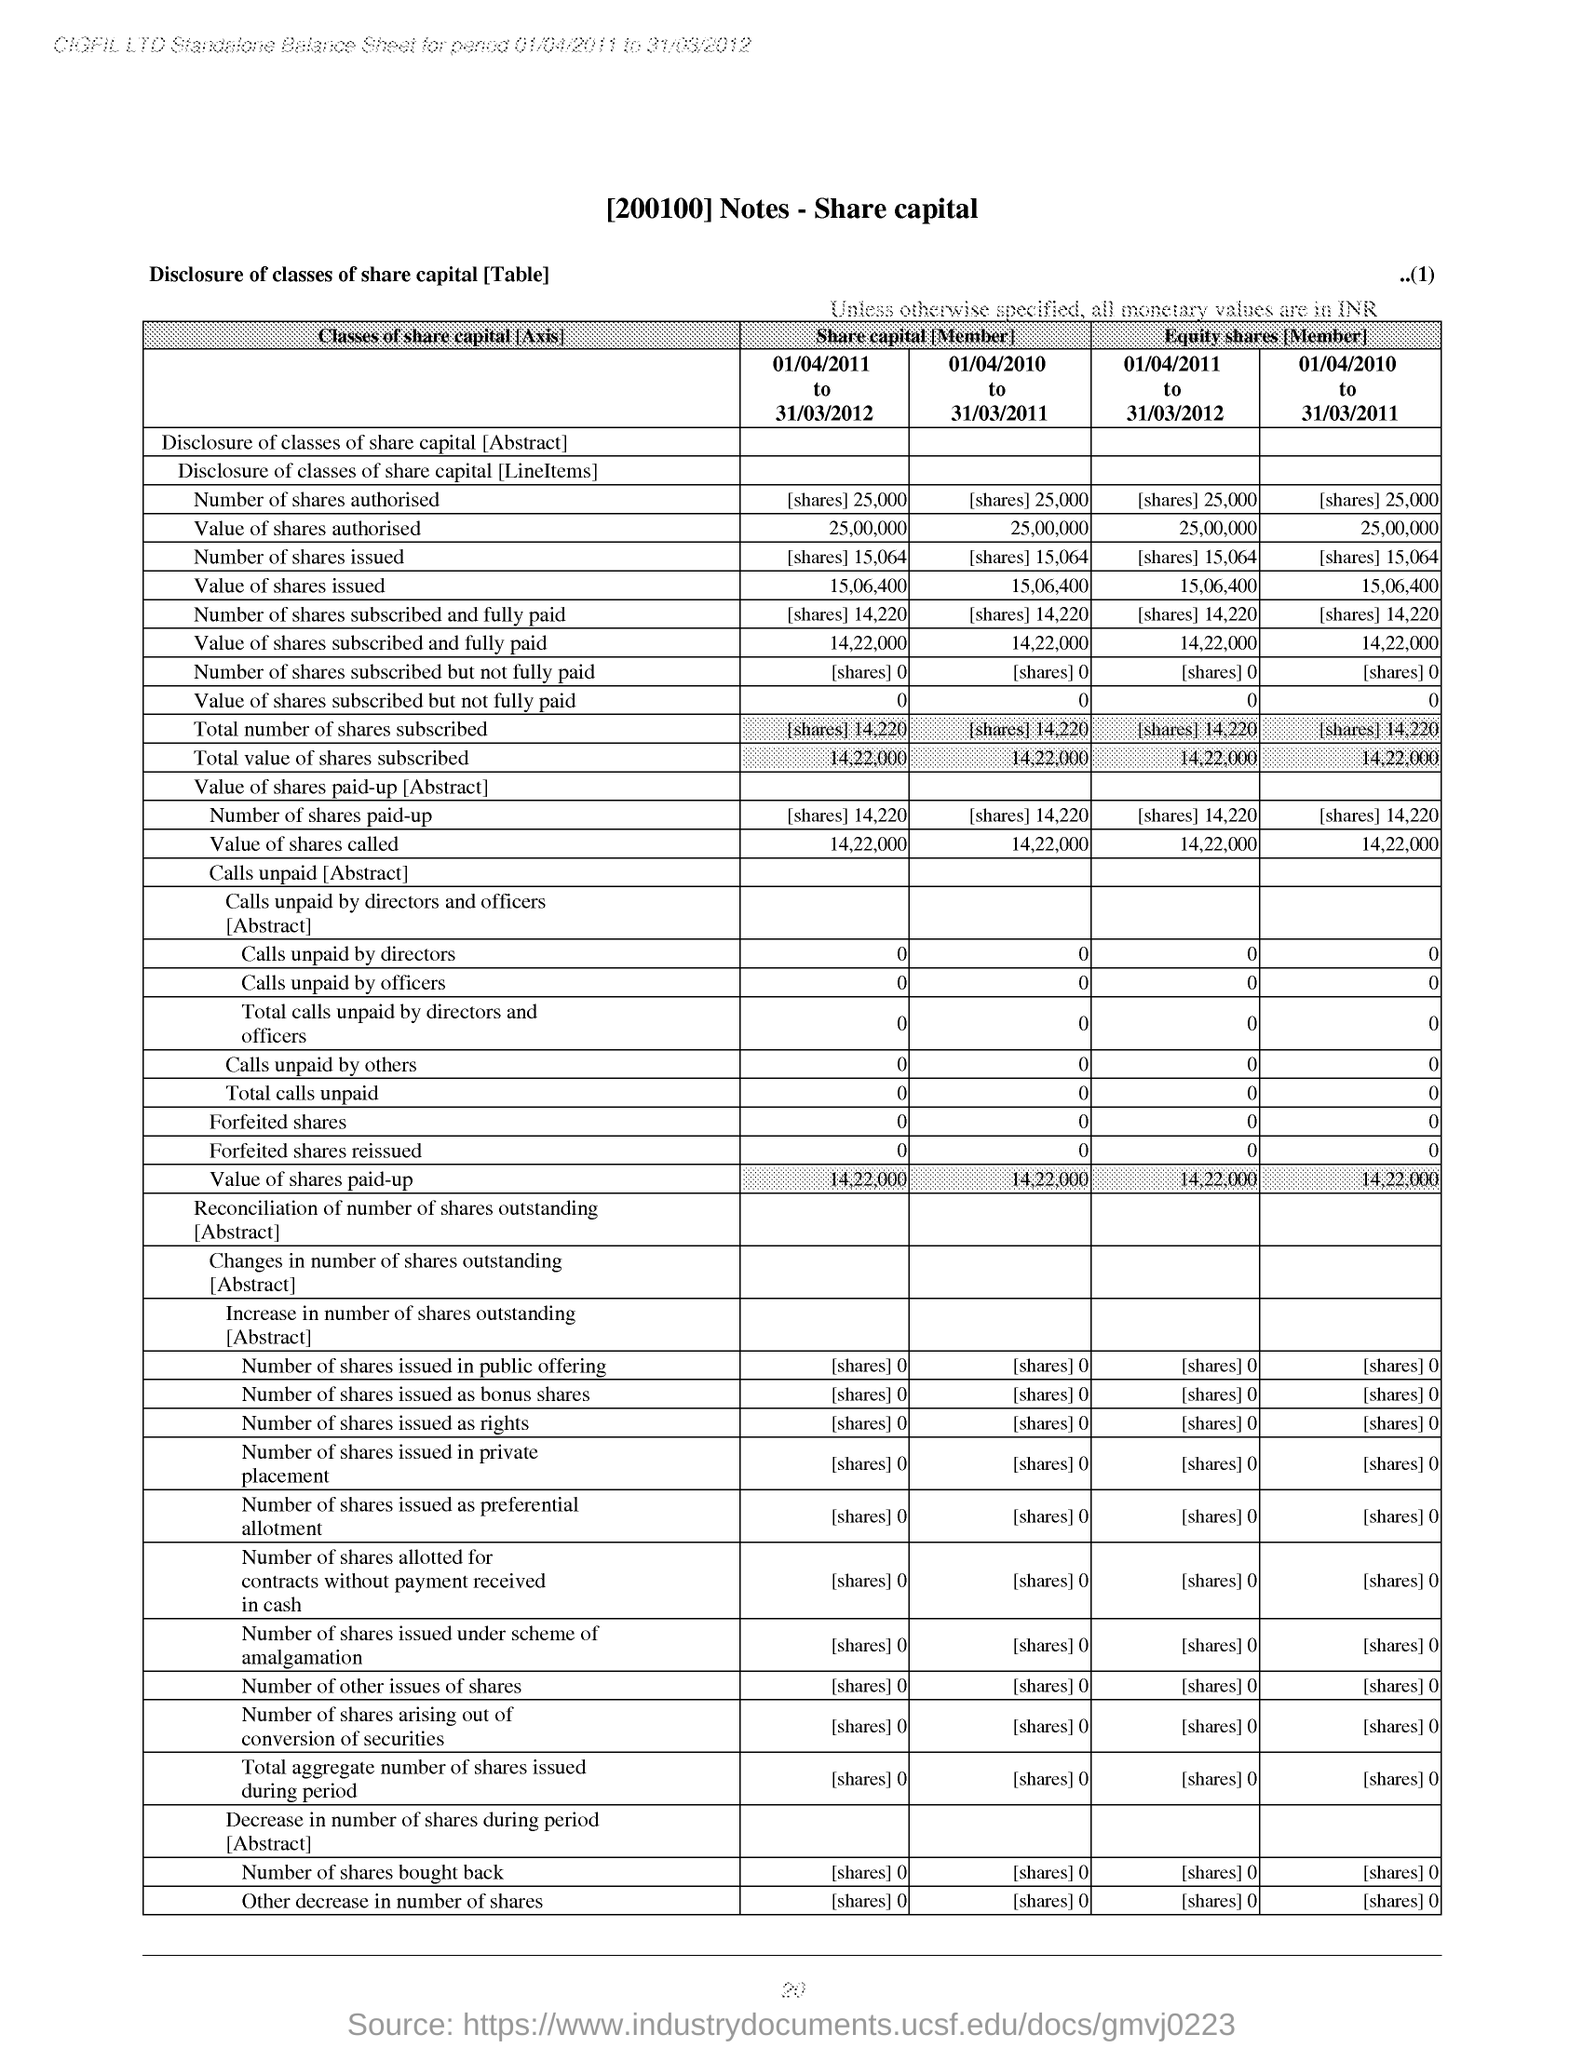What is the Page Number?
Your answer should be very brief. 20. 